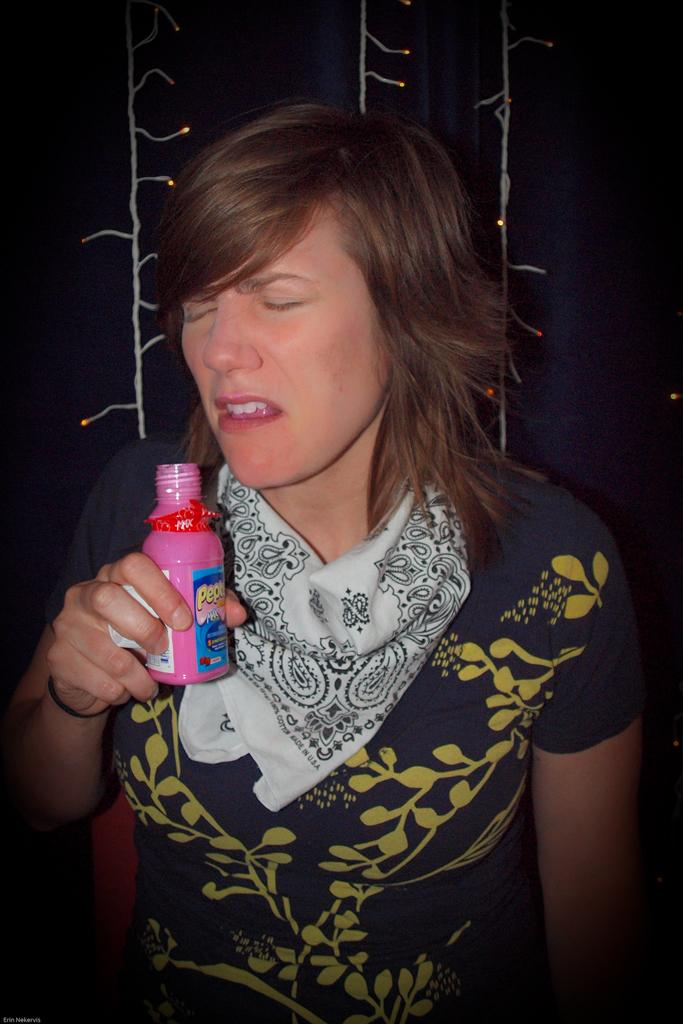Who is present in the image? There is a woman in the image. What is the woman holding in her hand? The woman is holding a bottle in her hand. What is the woman's facial expression in the image? The woman has her eyes closed in the image. What can be seen in the background of the image? There are lights visible in the background of the image. What type of gold rings can be seen on the woman's fingers in the image? There are no gold rings visible on the woman's fingers in the image. What type of celery is the woman holding in her hand instead of a bottle? The woman is not holding celery in her hand; she is holding a bottle, as stated in the facts. 